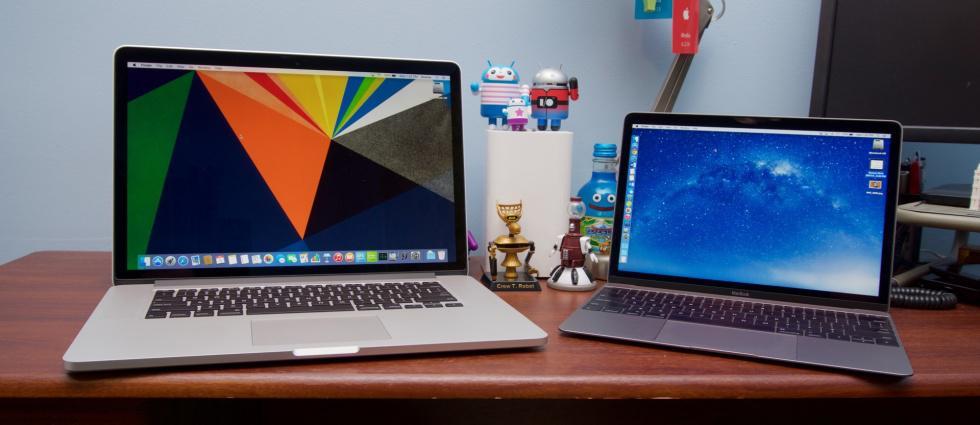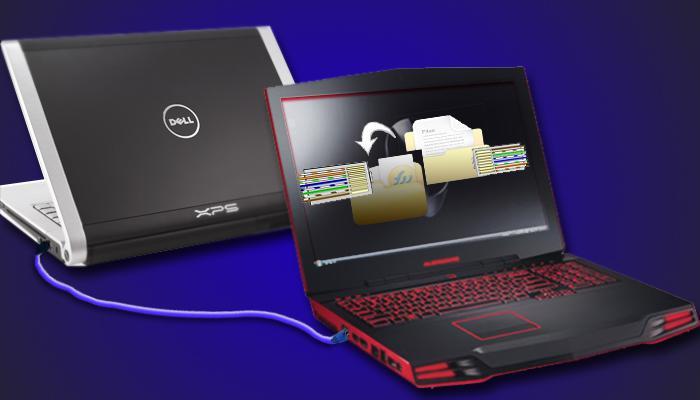The first image is the image on the left, the second image is the image on the right. For the images shown, is this caption "The top cover of one laptop is visible." true? Answer yes or no. Yes. The first image is the image on the left, the second image is the image on the right. Analyze the images presented: Is the assertion "Two laptops can be seen connected by a crossover cable." valid? Answer yes or no. Yes. 